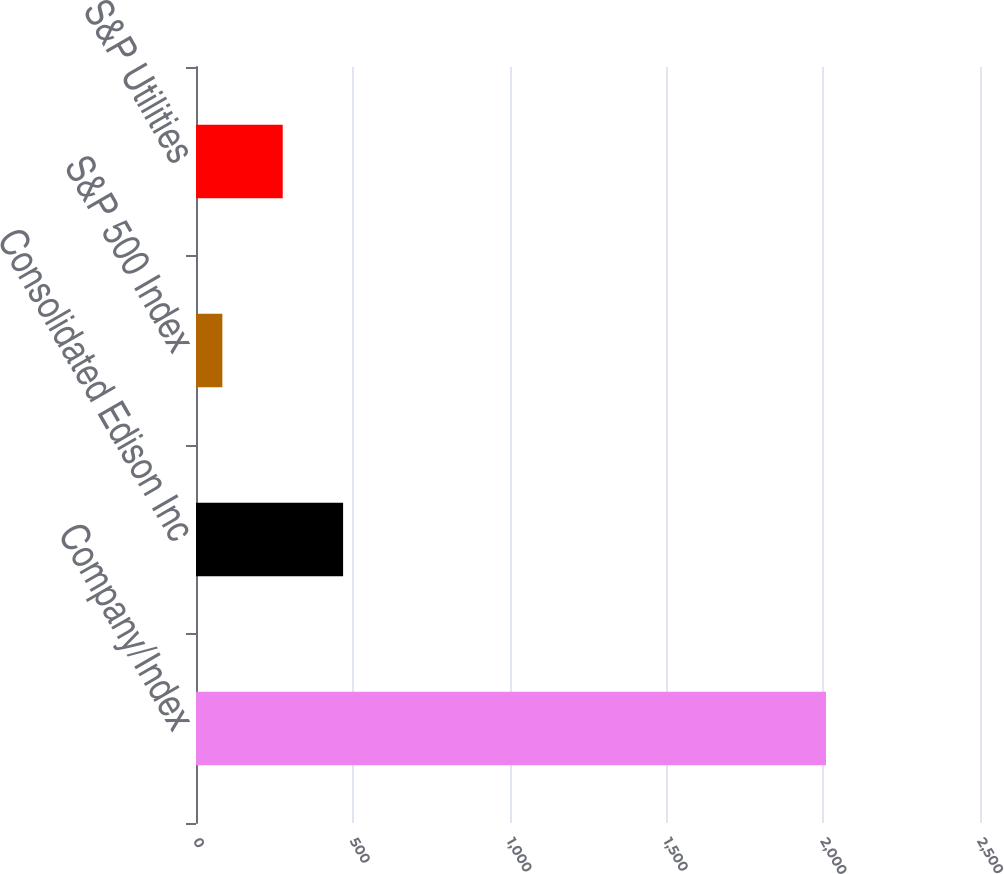Convert chart. <chart><loc_0><loc_0><loc_500><loc_500><bar_chart><fcel>Company/Index<fcel>Consolidated Edison Inc<fcel>S&P 500 Index<fcel>S&P Utilities<nl><fcel>2009<fcel>469.05<fcel>84.05<fcel>276.55<nl></chart> 